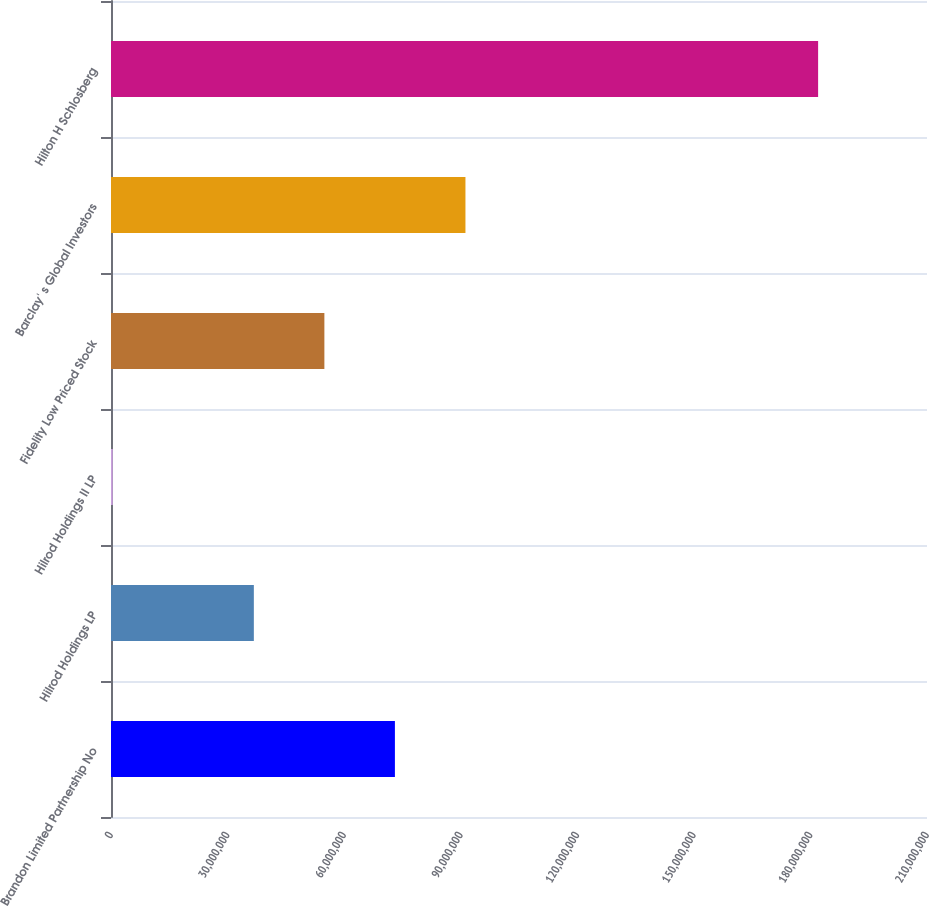Convert chart to OTSL. <chart><loc_0><loc_0><loc_500><loc_500><bar_chart><fcel>Brandon Limited Partnership No<fcel>Hilrod Holdings LP<fcel>Hilrod Holdings II LP<fcel>Fidelity Low Priced Stock<fcel>Barclay' s Global Investors<fcel>Hilton H Schlosberg<nl><fcel>7.30658e+07<fcel>3.67617e+07<fcel>457552<fcel>5.49137e+07<fcel>9.12178e+07<fcel>1.81978e+08<nl></chart> 